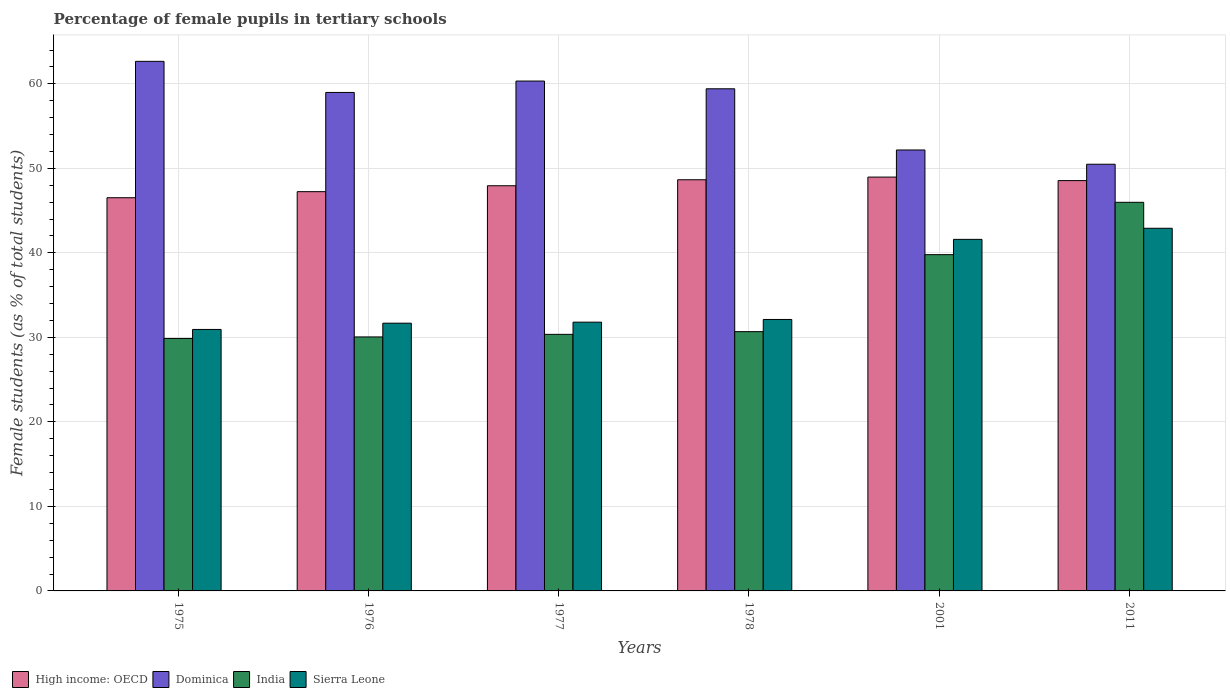How many bars are there on the 3rd tick from the right?
Your answer should be compact. 4. What is the label of the 2nd group of bars from the left?
Offer a terse response. 1976. What is the percentage of female pupils in tertiary schools in High income: OECD in 1978?
Offer a very short reply. 48.65. Across all years, what is the maximum percentage of female pupils in tertiary schools in Sierra Leone?
Your response must be concise. 42.91. Across all years, what is the minimum percentage of female pupils in tertiary schools in India?
Your response must be concise. 29.87. In which year was the percentage of female pupils in tertiary schools in High income: OECD maximum?
Offer a terse response. 2001. In which year was the percentage of female pupils in tertiary schools in India minimum?
Your answer should be very brief. 1975. What is the total percentage of female pupils in tertiary schools in Dominica in the graph?
Make the answer very short. 344.04. What is the difference between the percentage of female pupils in tertiary schools in Dominica in 1977 and that in 2011?
Your answer should be compact. 9.84. What is the difference between the percentage of female pupils in tertiary schools in Sierra Leone in 2011 and the percentage of female pupils in tertiary schools in India in 1976?
Your answer should be compact. 12.86. What is the average percentage of female pupils in tertiary schools in Sierra Leone per year?
Give a very brief answer. 35.17. In the year 2001, what is the difference between the percentage of female pupils in tertiary schools in India and percentage of female pupils in tertiary schools in Dominica?
Ensure brevity in your answer.  -12.39. What is the ratio of the percentage of female pupils in tertiary schools in India in 1977 to that in 1978?
Your answer should be compact. 0.99. What is the difference between the highest and the second highest percentage of female pupils in tertiary schools in India?
Make the answer very short. 6.19. What is the difference between the highest and the lowest percentage of female pupils in tertiary schools in Dominica?
Offer a terse response. 12.17. Is the sum of the percentage of female pupils in tertiary schools in India in 1975 and 1976 greater than the maximum percentage of female pupils in tertiary schools in Dominica across all years?
Offer a very short reply. No. Is it the case that in every year, the sum of the percentage of female pupils in tertiary schools in India and percentage of female pupils in tertiary schools in High income: OECD is greater than the percentage of female pupils in tertiary schools in Sierra Leone?
Ensure brevity in your answer.  Yes. How many bars are there?
Ensure brevity in your answer.  24. Are all the bars in the graph horizontal?
Make the answer very short. No. How many years are there in the graph?
Offer a terse response. 6. What is the difference between two consecutive major ticks on the Y-axis?
Your response must be concise. 10. Does the graph contain any zero values?
Make the answer very short. No. Does the graph contain grids?
Give a very brief answer. Yes. How are the legend labels stacked?
Your answer should be compact. Horizontal. What is the title of the graph?
Ensure brevity in your answer.  Percentage of female pupils in tertiary schools. What is the label or title of the Y-axis?
Give a very brief answer. Female students (as % of total students). What is the Female students (as % of total students) of High income: OECD in 1975?
Your response must be concise. 46.52. What is the Female students (as % of total students) in Dominica in 1975?
Your response must be concise. 62.66. What is the Female students (as % of total students) of India in 1975?
Offer a terse response. 29.87. What is the Female students (as % of total students) in Sierra Leone in 1975?
Provide a succinct answer. 30.94. What is the Female students (as % of total students) in High income: OECD in 1976?
Offer a very short reply. 47.24. What is the Female students (as % of total students) of Dominica in 1976?
Provide a succinct answer. 58.98. What is the Female students (as % of total students) of India in 1976?
Your answer should be compact. 30.05. What is the Female students (as % of total students) of Sierra Leone in 1976?
Offer a very short reply. 31.68. What is the Female students (as % of total students) in High income: OECD in 1977?
Make the answer very short. 47.94. What is the Female students (as % of total students) of Dominica in 1977?
Provide a succinct answer. 60.33. What is the Female students (as % of total students) in India in 1977?
Keep it short and to the point. 30.36. What is the Female students (as % of total students) in Sierra Leone in 1977?
Provide a short and direct response. 31.8. What is the Female students (as % of total students) in High income: OECD in 1978?
Your answer should be very brief. 48.65. What is the Female students (as % of total students) of Dominica in 1978?
Provide a succinct answer. 59.41. What is the Female students (as % of total students) in India in 1978?
Your response must be concise. 30.68. What is the Female students (as % of total students) of Sierra Leone in 1978?
Give a very brief answer. 32.12. What is the Female students (as % of total students) of High income: OECD in 2001?
Offer a terse response. 48.97. What is the Female students (as % of total students) of Dominica in 2001?
Provide a short and direct response. 52.17. What is the Female students (as % of total students) in India in 2001?
Give a very brief answer. 39.79. What is the Female students (as % of total students) in Sierra Leone in 2001?
Ensure brevity in your answer.  41.6. What is the Female students (as % of total students) of High income: OECD in 2011?
Your answer should be compact. 48.55. What is the Female students (as % of total students) of Dominica in 2011?
Your answer should be compact. 50.48. What is the Female students (as % of total students) in India in 2011?
Ensure brevity in your answer.  45.98. What is the Female students (as % of total students) of Sierra Leone in 2011?
Provide a short and direct response. 42.91. Across all years, what is the maximum Female students (as % of total students) in High income: OECD?
Give a very brief answer. 48.97. Across all years, what is the maximum Female students (as % of total students) in Dominica?
Your response must be concise. 62.66. Across all years, what is the maximum Female students (as % of total students) in India?
Keep it short and to the point. 45.98. Across all years, what is the maximum Female students (as % of total students) of Sierra Leone?
Your answer should be compact. 42.91. Across all years, what is the minimum Female students (as % of total students) of High income: OECD?
Provide a succinct answer. 46.52. Across all years, what is the minimum Female students (as % of total students) of Dominica?
Provide a succinct answer. 50.48. Across all years, what is the minimum Female students (as % of total students) in India?
Provide a short and direct response. 29.87. Across all years, what is the minimum Female students (as % of total students) of Sierra Leone?
Offer a terse response. 30.94. What is the total Female students (as % of total students) of High income: OECD in the graph?
Offer a terse response. 287.87. What is the total Female students (as % of total students) in Dominica in the graph?
Offer a very short reply. 344.04. What is the total Female students (as % of total students) of India in the graph?
Offer a very short reply. 206.73. What is the total Female students (as % of total students) of Sierra Leone in the graph?
Your answer should be very brief. 211.04. What is the difference between the Female students (as % of total students) of High income: OECD in 1975 and that in 1976?
Provide a succinct answer. -0.72. What is the difference between the Female students (as % of total students) in Dominica in 1975 and that in 1976?
Give a very brief answer. 3.68. What is the difference between the Female students (as % of total students) in India in 1975 and that in 1976?
Provide a short and direct response. -0.18. What is the difference between the Female students (as % of total students) of Sierra Leone in 1975 and that in 1976?
Offer a terse response. -0.74. What is the difference between the Female students (as % of total students) in High income: OECD in 1975 and that in 1977?
Give a very brief answer. -1.42. What is the difference between the Female students (as % of total students) of Dominica in 1975 and that in 1977?
Your answer should be compact. 2.33. What is the difference between the Female students (as % of total students) of India in 1975 and that in 1977?
Offer a terse response. -0.49. What is the difference between the Female students (as % of total students) of Sierra Leone in 1975 and that in 1977?
Your answer should be compact. -0.86. What is the difference between the Female students (as % of total students) of High income: OECD in 1975 and that in 1978?
Your answer should be compact. -2.13. What is the difference between the Female students (as % of total students) in Dominica in 1975 and that in 1978?
Provide a short and direct response. 3.25. What is the difference between the Female students (as % of total students) of India in 1975 and that in 1978?
Your answer should be compact. -0.81. What is the difference between the Female students (as % of total students) in Sierra Leone in 1975 and that in 1978?
Ensure brevity in your answer.  -1.18. What is the difference between the Female students (as % of total students) in High income: OECD in 1975 and that in 2001?
Provide a succinct answer. -2.44. What is the difference between the Female students (as % of total students) of Dominica in 1975 and that in 2001?
Offer a terse response. 10.49. What is the difference between the Female students (as % of total students) of India in 1975 and that in 2001?
Provide a succinct answer. -9.92. What is the difference between the Female students (as % of total students) in Sierra Leone in 1975 and that in 2001?
Provide a short and direct response. -10.66. What is the difference between the Female students (as % of total students) in High income: OECD in 1975 and that in 2011?
Provide a short and direct response. -2.03. What is the difference between the Female students (as % of total students) in Dominica in 1975 and that in 2011?
Your answer should be very brief. 12.17. What is the difference between the Female students (as % of total students) of India in 1975 and that in 2011?
Give a very brief answer. -16.11. What is the difference between the Female students (as % of total students) in Sierra Leone in 1975 and that in 2011?
Give a very brief answer. -11.97. What is the difference between the Female students (as % of total students) of High income: OECD in 1976 and that in 1977?
Provide a short and direct response. -0.7. What is the difference between the Female students (as % of total students) of Dominica in 1976 and that in 1977?
Your answer should be very brief. -1.35. What is the difference between the Female students (as % of total students) in India in 1976 and that in 1977?
Provide a succinct answer. -0.3. What is the difference between the Female students (as % of total students) in Sierra Leone in 1976 and that in 1977?
Ensure brevity in your answer.  -0.12. What is the difference between the Female students (as % of total students) of High income: OECD in 1976 and that in 1978?
Offer a very short reply. -1.41. What is the difference between the Female students (as % of total students) in Dominica in 1976 and that in 1978?
Your answer should be very brief. -0.43. What is the difference between the Female students (as % of total students) of India in 1976 and that in 1978?
Your answer should be compact. -0.63. What is the difference between the Female students (as % of total students) of Sierra Leone in 1976 and that in 1978?
Make the answer very short. -0.44. What is the difference between the Female students (as % of total students) in High income: OECD in 1976 and that in 2001?
Your answer should be compact. -1.72. What is the difference between the Female students (as % of total students) of Dominica in 1976 and that in 2001?
Offer a terse response. 6.81. What is the difference between the Female students (as % of total students) in India in 1976 and that in 2001?
Keep it short and to the point. -9.73. What is the difference between the Female students (as % of total students) in Sierra Leone in 1976 and that in 2001?
Provide a succinct answer. -9.92. What is the difference between the Female students (as % of total students) of High income: OECD in 1976 and that in 2011?
Your answer should be compact. -1.31. What is the difference between the Female students (as % of total students) in Dominica in 1976 and that in 2011?
Keep it short and to the point. 8.5. What is the difference between the Female students (as % of total students) of India in 1976 and that in 2011?
Ensure brevity in your answer.  -15.93. What is the difference between the Female students (as % of total students) in Sierra Leone in 1976 and that in 2011?
Keep it short and to the point. -11.23. What is the difference between the Female students (as % of total students) of High income: OECD in 1977 and that in 1978?
Your response must be concise. -0.71. What is the difference between the Female students (as % of total students) of Dominica in 1977 and that in 1978?
Offer a very short reply. 0.92. What is the difference between the Female students (as % of total students) in India in 1977 and that in 1978?
Offer a terse response. -0.32. What is the difference between the Female students (as % of total students) of Sierra Leone in 1977 and that in 1978?
Offer a terse response. -0.32. What is the difference between the Female students (as % of total students) of High income: OECD in 1977 and that in 2001?
Your response must be concise. -1.02. What is the difference between the Female students (as % of total students) of Dominica in 1977 and that in 2001?
Offer a terse response. 8.16. What is the difference between the Female students (as % of total students) of India in 1977 and that in 2001?
Give a very brief answer. -9.43. What is the difference between the Female students (as % of total students) of Sierra Leone in 1977 and that in 2001?
Ensure brevity in your answer.  -9.8. What is the difference between the Female students (as % of total students) in High income: OECD in 1977 and that in 2011?
Your answer should be compact. -0.61. What is the difference between the Female students (as % of total students) of Dominica in 1977 and that in 2011?
Your answer should be very brief. 9.84. What is the difference between the Female students (as % of total students) of India in 1977 and that in 2011?
Offer a terse response. -15.62. What is the difference between the Female students (as % of total students) in Sierra Leone in 1977 and that in 2011?
Ensure brevity in your answer.  -11.11. What is the difference between the Female students (as % of total students) of High income: OECD in 1978 and that in 2001?
Your answer should be compact. -0.32. What is the difference between the Female students (as % of total students) in Dominica in 1978 and that in 2001?
Offer a very short reply. 7.24. What is the difference between the Female students (as % of total students) in India in 1978 and that in 2001?
Your answer should be very brief. -9.11. What is the difference between the Female students (as % of total students) in Sierra Leone in 1978 and that in 2001?
Your answer should be compact. -9.48. What is the difference between the Female students (as % of total students) in High income: OECD in 1978 and that in 2011?
Make the answer very short. 0.1. What is the difference between the Female students (as % of total students) in Dominica in 1978 and that in 2011?
Ensure brevity in your answer.  8.93. What is the difference between the Female students (as % of total students) in India in 1978 and that in 2011?
Give a very brief answer. -15.3. What is the difference between the Female students (as % of total students) of Sierra Leone in 1978 and that in 2011?
Make the answer very short. -10.79. What is the difference between the Female students (as % of total students) in High income: OECD in 2001 and that in 2011?
Your answer should be compact. 0.42. What is the difference between the Female students (as % of total students) in Dominica in 2001 and that in 2011?
Offer a very short reply. 1.69. What is the difference between the Female students (as % of total students) of India in 2001 and that in 2011?
Keep it short and to the point. -6.19. What is the difference between the Female students (as % of total students) in Sierra Leone in 2001 and that in 2011?
Make the answer very short. -1.31. What is the difference between the Female students (as % of total students) of High income: OECD in 1975 and the Female students (as % of total students) of Dominica in 1976?
Your answer should be very brief. -12.46. What is the difference between the Female students (as % of total students) in High income: OECD in 1975 and the Female students (as % of total students) in India in 1976?
Offer a very short reply. 16.47. What is the difference between the Female students (as % of total students) of High income: OECD in 1975 and the Female students (as % of total students) of Sierra Leone in 1976?
Your answer should be compact. 14.84. What is the difference between the Female students (as % of total students) in Dominica in 1975 and the Female students (as % of total students) in India in 1976?
Provide a short and direct response. 32.61. What is the difference between the Female students (as % of total students) of Dominica in 1975 and the Female students (as % of total students) of Sierra Leone in 1976?
Your answer should be compact. 30.98. What is the difference between the Female students (as % of total students) of India in 1975 and the Female students (as % of total students) of Sierra Leone in 1976?
Provide a short and direct response. -1.81. What is the difference between the Female students (as % of total students) in High income: OECD in 1975 and the Female students (as % of total students) in Dominica in 1977?
Your answer should be compact. -13.81. What is the difference between the Female students (as % of total students) in High income: OECD in 1975 and the Female students (as % of total students) in India in 1977?
Your answer should be very brief. 16.17. What is the difference between the Female students (as % of total students) in High income: OECD in 1975 and the Female students (as % of total students) in Sierra Leone in 1977?
Ensure brevity in your answer.  14.72. What is the difference between the Female students (as % of total students) of Dominica in 1975 and the Female students (as % of total students) of India in 1977?
Offer a terse response. 32.3. What is the difference between the Female students (as % of total students) in Dominica in 1975 and the Female students (as % of total students) in Sierra Leone in 1977?
Offer a very short reply. 30.86. What is the difference between the Female students (as % of total students) of India in 1975 and the Female students (as % of total students) of Sierra Leone in 1977?
Provide a short and direct response. -1.93. What is the difference between the Female students (as % of total students) of High income: OECD in 1975 and the Female students (as % of total students) of Dominica in 1978?
Keep it short and to the point. -12.89. What is the difference between the Female students (as % of total students) of High income: OECD in 1975 and the Female students (as % of total students) of India in 1978?
Provide a succinct answer. 15.85. What is the difference between the Female students (as % of total students) in High income: OECD in 1975 and the Female students (as % of total students) in Sierra Leone in 1978?
Make the answer very short. 14.4. What is the difference between the Female students (as % of total students) in Dominica in 1975 and the Female students (as % of total students) in India in 1978?
Make the answer very short. 31.98. What is the difference between the Female students (as % of total students) in Dominica in 1975 and the Female students (as % of total students) in Sierra Leone in 1978?
Provide a succinct answer. 30.54. What is the difference between the Female students (as % of total students) in India in 1975 and the Female students (as % of total students) in Sierra Leone in 1978?
Offer a terse response. -2.25. What is the difference between the Female students (as % of total students) in High income: OECD in 1975 and the Female students (as % of total students) in Dominica in 2001?
Provide a succinct answer. -5.65. What is the difference between the Female students (as % of total students) in High income: OECD in 1975 and the Female students (as % of total students) in India in 2001?
Offer a terse response. 6.74. What is the difference between the Female students (as % of total students) of High income: OECD in 1975 and the Female students (as % of total students) of Sierra Leone in 2001?
Offer a terse response. 4.93. What is the difference between the Female students (as % of total students) in Dominica in 1975 and the Female students (as % of total students) in India in 2001?
Offer a very short reply. 22.87. What is the difference between the Female students (as % of total students) in Dominica in 1975 and the Female students (as % of total students) in Sierra Leone in 2001?
Make the answer very short. 21.06. What is the difference between the Female students (as % of total students) in India in 1975 and the Female students (as % of total students) in Sierra Leone in 2001?
Your response must be concise. -11.73. What is the difference between the Female students (as % of total students) of High income: OECD in 1975 and the Female students (as % of total students) of Dominica in 2011?
Provide a succinct answer. -3.96. What is the difference between the Female students (as % of total students) in High income: OECD in 1975 and the Female students (as % of total students) in India in 2011?
Ensure brevity in your answer.  0.54. What is the difference between the Female students (as % of total students) of High income: OECD in 1975 and the Female students (as % of total students) of Sierra Leone in 2011?
Ensure brevity in your answer.  3.61. What is the difference between the Female students (as % of total students) of Dominica in 1975 and the Female students (as % of total students) of India in 2011?
Ensure brevity in your answer.  16.68. What is the difference between the Female students (as % of total students) of Dominica in 1975 and the Female students (as % of total students) of Sierra Leone in 2011?
Provide a succinct answer. 19.75. What is the difference between the Female students (as % of total students) in India in 1975 and the Female students (as % of total students) in Sierra Leone in 2011?
Provide a succinct answer. -13.04. What is the difference between the Female students (as % of total students) of High income: OECD in 1976 and the Female students (as % of total students) of Dominica in 1977?
Offer a terse response. -13.09. What is the difference between the Female students (as % of total students) of High income: OECD in 1976 and the Female students (as % of total students) of India in 1977?
Ensure brevity in your answer.  16.88. What is the difference between the Female students (as % of total students) of High income: OECD in 1976 and the Female students (as % of total students) of Sierra Leone in 1977?
Keep it short and to the point. 15.44. What is the difference between the Female students (as % of total students) in Dominica in 1976 and the Female students (as % of total students) in India in 1977?
Your answer should be compact. 28.62. What is the difference between the Female students (as % of total students) of Dominica in 1976 and the Female students (as % of total students) of Sierra Leone in 1977?
Provide a succinct answer. 27.18. What is the difference between the Female students (as % of total students) in India in 1976 and the Female students (as % of total students) in Sierra Leone in 1977?
Offer a terse response. -1.75. What is the difference between the Female students (as % of total students) of High income: OECD in 1976 and the Female students (as % of total students) of Dominica in 1978?
Provide a short and direct response. -12.17. What is the difference between the Female students (as % of total students) in High income: OECD in 1976 and the Female students (as % of total students) in India in 1978?
Give a very brief answer. 16.56. What is the difference between the Female students (as % of total students) of High income: OECD in 1976 and the Female students (as % of total students) of Sierra Leone in 1978?
Your answer should be very brief. 15.12. What is the difference between the Female students (as % of total students) in Dominica in 1976 and the Female students (as % of total students) in India in 1978?
Keep it short and to the point. 28.3. What is the difference between the Female students (as % of total students) of Dominica in 1976 and the Female students (as % of total students) of Sierra Leone in 1978?
Offer a very short reply. 26.86. What is the difference between the Female students (as % of total students) of India in 1976 and the Female students (as % of total students) of Sierra Leone in 1978?
Provide a succinct answer. -2.07. What is the difference between the Female students (as % of total students) of High income: OECD in 1976 and the Female students (as % of total students) of Dominica in 2001?
Provide a short and direct response. -4.93. What is the difference between the Female students (as % of total students) of High income: OECD in 1976 and the Female students (as % of total students) of India in 2001?
Ensure brevity in your answer.  7.45. What is the difference between the Female students (as % of total students) of High income: OECD in 1976 and the Female students (as % of total students) of Sierra Leone in 2001?
Ensure brevity in your answer.  5.64. What is the difference between the Female students (as % of total students) of Dominica in 1976 and the Female students (as % of total students) of India in 2001?
Your answer should be very brief. 19.19. What is the difference between the Female students (as % of total students) in Dominica in 1976 and the Female students (as % of total students) in Sierra Leone in 2001?
Your answer should be very brief. 17.38. What is the difference between the Female students (as % of total students) in India in 1976 and the Female students (as % of total students) in Sierra Leone in 2001?
Give a very brief answer. -11.54. What is the difference between the Female students (as % of total students) of High income: OECD in 1976 and the Female students (as % of total students) of Dominica in 2011?
Your response must be concise. -3.24. What is the difference between the Female students (as % of total students) in High income: OECD in 1976 and the Female students (as % of total students) in India in 2011?
Make the answer very short. 1.26. What is the difference between the Female students (as % of total students) of High income: OECD in 1976 and the Female students (as % of total students) of Sierra Leone in 2011?
Give a very brief answer. 4.33. What is the difference between the Female students (as % of total students) of Dominica in 1976 and the Female students (as % of total students) of India in 2011?
Offer a terse response. 13. What is the difference between the Female students (as % of total students) in Dominica in 1976 and the Female students (as % of total students) in Sierra Leone in 2011?
Your answer should be very brief. 16.07. What is the difference between the Female students (as % of total students) of India in 1976 and the Female students (as % of total students) of Sierra Leone in 2011?
Provide a short and direct response. -12.86. What is the difference between the Female students (as % of total students) of High income: OECD in 1977 and the Female students (as % of total students) of Dominica in 1978?
Give a very brief answer. -11.47. What is the difference between the Female students (as % of total students) of High income: OECD in 1977 and the Female students (as % of total students) of India in 1978?
Make the answer very short. 17.26. What is the difference between the Female students (as % of total students) of High income: OECD in 1977 and the Female students (as % of total students) of Sierra Leone in 1978?
Make the answer very short. 15.82. What is the difference between the Female students (as % of total students) in Dominica in 1977 and the Female students (as % of total students) in India in 1978?
Keep it short and to the point. 29.65. What is the difference between the Female students (as % of total students) of Dominica in 1977 and the Female students (as % of total students) of Sierra Leone in 1978?
Your response must be concise. 28.21. What is the difference between the Female students (as % of total students) in India in 1977 and the Female students (as % of total students) in Sierra Leone in 1978?
Your answer should be very brief. -1.76. What is the difference between the Female students (as % of total students) in High income: OECD in 1977 and the Female students (as % of total students) in Dominica in 2001?
Your response must be concise. -4.23. What is the difference between the Female students (as % of total students) of High income: OECD in 1977 and the Female students (as % of total students) of India in 2001?
Your answer should be compact. 8.15. What is the difference between the Female students (as % of total students) in High income: OECD in 1977 and the Female students (as % of total students) in Sierra Leone in 2001?
Make the answer very short. 6.34. What is the difference between the Female students (as % of total students) of Dominica in 1977 and the Female students (as % of total students) of India in 2001?
Provide a short and direct response. 20.54. What is the difference between the Female students (as % of total students) of Dominica in 1977 and the Female students (as % of total students) of Sierra Leone in 2001?
Your answer should be very brief. 18.73. What is the difference between the Female students (as % of total students) of India in 1977 and the Female students (as % of total students) of Sierra Leone in 2001?
Your answer should be very brief. -11.24. What is the difference between the Female students (as % of total students) of High income: OECD in 1977 and the Female students (as % of total students) of Dominica in 2011?
Offer a very short reply. -2.54. What is the difference between the Female students (as % of total students) in High income: OECD in 1977 and the Female students (as % of total students) in India in 2011?
Provide a short and direct response. 1.96. What is the difference between the Female students (as % of total students) of High income: OECD in 1977 and the Female students (as % of total students) of Sierra Leone in 2011?
Provide a succinct answer. 5.03. What is the difference between the Female students (as % of total students) of Dominica in 1977 and the Female students (as % of total students) of India in 2011?
Ensure brevity in your answer.  14.35. What is the difference between the Female students (as % of total students) of Dominica in 1977 and the Female students (as % of total students) of Sierra Leone in 2011?
Offer a terse response. 17.42. What is the difference between the Female students (as % of total students) in India in 1977 and the Female students (as % of total students) in Sierra Leone in 2011?
Give a very brief answer. -12.55. What is the difference between the Female students (as % of total students) in High income: OECD in 1978 and the Female students (as % of total students) in Dominica in 2001?
Make the answer very short. -3.52. What is the difference between the Female students (as % of total students) of High income: OECD in 1978 and the Female students (as % of total students) of India in 2001?
Provide a short and direct response. 8.86. What is the difference between the Female students (as % of total students) in High income: OECD in 1978 and the Female students (as % of total students) in Sierra Leone in 2001?
Offer a terse response. 7.05. What is the difference between the Female students (as % of total students) in Dominica in 1978 and the Female students (as % of total students) in India in 2001?
Provide a succinct answer. 19.63. What is the difference between the Female students (as % of total students) of Dominica in 1978 and the Female students (as % of total students) of Sierra Leone in 2001?
Keep it short and to the point. 17.82. What is the difference between the Female students (as % of total students) of India in 1978 and the Female students (as % of total students) of Sierra Leone in 2001?
Offer a very short reply. -10.92. What is the difference between the Female students (as % of total students) in High income: OECD in 1978 and the Female students (as % of total students) in Dominica in 2011?
Your response must be concise. -1.83. What is the difference between the Female students (as % of total students) of High income: OECD in 1978 and the Female students (as % of total students) of India in 2011?
Give a very brief answer. 2.67. What is the difference between the Female students (as % of total students) in High income: OECD in 1978 and the Female students (as % of total students) in Sierra Leone in 2011?
Provide a short and direct response. 5.74. What is the difference between the Female students (as % of total students) of Dominica in 1978 and the Female students (as % of total students) of India in 2011?
Your answer should be very brief. 13.43. What is the difference between the Female students (as % of total students) in Dominica in 1978 and the Female students (as % of total students) in Sierra Leone in 2011?
Give a very brief answer. 16.5. What is the difference between the Female students (as % of total students) in India in 1978 and the Female students (as % of total students) in Sierra Leone in 2011?
Give a very brief answer. -12.23. What is the difference between the Female students (as % of total students) in High income: OECD in 2001 and the Female students (as % of total students) in Dominica in 2011?
Offer a terse response. -1.52. What is the difference between the Female students (as % of total students) of High income: OECD in 2001 and the Female students (as % of total students) of India in 2011?
Your response must be concise. 2.98. What is the difference between the Female students (as % of total students) of High income: OECD in 2001 and the Female students (as % of total students) of Sierra Leone in 2011?
Ensure brevity in your answer.  6.06. What is the difference between the Female students (as % of total students) of Dominica in 2001 and the Female students (as % of total students) of India in 2011?
Ensure brevity in your answer.  6.19. What is the difference between the Female students (as % of total students) of Dominica in 2001 and the Female students (as % of total students) of Sierra Leone in 2011?
Offer a very short reply. 9.26. What is the difference between the Female students (as % of total students) of India in 2001 and the Female students (as % of total students) of Sierra Leone in 2011?
Keep it short and to the point. -3.12. What is the average Female students (as % of total students) in High income: OECD per year?
Your answer should be very brief. 47.98. What is the average Female students (as % of total students) in Dominica per year?
Make the answer very short. 57.34. What is the average Female students (as % of total students) in India per year?
Provide a short and direct response. 34.45. What is the average Female students (as % of total students) of Sierra Leone per year?
Your answer should be very brief. 35.17. In the year 1975, what is the difference between the Female students (as % of total students) in High income: OECD and Female students (as % of total students) in Dominica?
Your answer should be compact. -16.14. In the year 1975, what is the difference between the Female students (as % of total students) of High income: OECD and Female students (as % of total students) of India?
Offer a very short reply. 16.65. In the year 1975, what is the difference between the Female students (as % of total students) of High income: OECD and Female students (as % of total students) of Sierra Leone?
Ensure brevity in your answer.  15.59. In the year 1975, what is the difference between the Female students (as % of total students) in Dominica and Female students (as % of total students) in India?
Provide a short and direct response. 32.79. In the year 1975, what is the difference between the Female students (as % of total students) of Dominica and Female students (as % of total students) of Sierra Leone?
Your answer should be compact. 31.72. In the year 1975, what is the difference between the Female students (as % of total students) of India and Female students (as % of total students) of Sierra Leone?
Provide a succinct answer. -1.07. In the year 1976, what is the difference between the Female students (as % of total students) of High income: OECD and Female students (as % of total students) of Dominica?
Offer a very short reply. -11.74. In the year 1976, what is the difference between the Female students (as % of total students) of High income: OECD and Female students (as % of total students) of India?
Your response must be concise. 17.19. In the year 1976, what is the difference between the Female students (as % of total students) in High income: OECD and Female students (as % of total students) in Sierra Leone?
Provide a succinct answer. 15.56. In the year 1976, what is the difference between the Female students (as % of total students) in Dominica and Female students (as % of total students) in India?
Your answer should be very brief. 28.93. In the year 1976, what is the difference between the Female students (as % of total students) of Dominica and Female students (as % of total students) of Sierra Leone?
Offer a terse response. 27.3. In the year 1976, what is the difference between the Female students (as % of total students) of India and Female students (as % of total students) of Sierra Leone?
Offer a very short reply. -1.63. In the year 1977, what is the difference between the Female students (as % of total students) in High income: OECD and Female students (as % of total students) in Dominica?
Offer a very short reply. -12.39. In the year 1977, what is the difference between the Female students (as % of total students) of High income: OECD and Female students (as % of total students) of India?
Make the answer very short. 17.58. In the year 1977, what is the difference between the Female students (as % of total students) of High income: OECD and Female students (as % of total students) of Sierra Leone?
Ensure brevity in your answer.  16.14. In the year 1977, what is the difference between the Female students (as % of total students) of Dominica and Female students (as % of total students) of India?
Your response must be concise. 29.97. In the year 1977, what is the difference between the Female students (as % of total students) of Dominica and Female students (as % of total students) of Sierra Leone?
Your response must be concise. 28.53. In the year 1977, what is the difference between the Female students (as % of total students) in India and Female students (as % of total students) in Sierra Leone?
Your response must be concise. -1.44. In the year 1978, what is the difference between the Female students (as % of total students) in High income: OECD and Female students (as % of total students) in Dominica?
Provide a succinct answer. -10.76. In the year 1978, what is the difference between the Female students (as % of total students) in High income: OECD and Female students (as % of total students) in India?
Offer a very short reply. 17.97. In the year 1978, what is the difference between the Female students (as % of total students) in High income: OECD and Female students (as % of total students) in Sierra Leone?
Provide a short and direct response. 16.53. In the year 1978, what is the difference between the Female students (as % of total students) of Dominica and Female students (as % of total students) of India?
Give a very brief answer. 28.74. In the year 1978, what is the difference between the Female students (as % of total students) of Dominica and Female students (as % of total students) of Sierra Leone?
Make the answer very short. 27.29. In the year 1978, what is the difference between the Female students (as % of total students) in India and Female students (as % of total students) in Sierra Leone?
Your answer should be very brief. -1.44. In the year 2001, what is the difference between the Female students (as % of total students) of High income: OECD and Female students (as % of total students) of Dominica?
Ensure brevity in your answer.  -3.21. In the year 2001, what is the difference between the Female students (as % of total students) of High income: OECD and Female students (as % of total students) of India?
Your response must be concise. 9.18. In the year 2001, what is the difference between the Female students (as % of total students) in High income: OECD and Female students (as % of total students) in Sierra Leone?
Keep it short and to the point. 7.37. In the year 2001, what is the difference between the Female students (as % of total students) in Dominica and Female students (as % of total students) in India?
Your response must be concise. 12.39. In the year 2001, what is the difference between the Female students (as % of total students) in Dominica and Female students (as % of total students) in Sierra Leone?
Offer a terse response. 10.58. In the year 2001, what is the difference between the Female students (as % of total students) of India and Female students (as % of total students) of Sierra Leone?
Offer a terse response. -1.81. In the year 2011, what is the difference between the Female students (as % of total students) in High income: OECD and Female students (as % of total students) in Dominica?
Your answer should be very brief. -1.94. In the year 2011, what is the difference between the Female students (as % of total students) in High income: OECD and Female students (as % of total students) in India?
Keep it short and to the point. 2.57. In the year 2011, what is the difference between the Female students (as % of total students) of High income: OECD and Female students (as % of total students) of Sierra Leone?
Offer a very short reply. 5.64. In the year 2011, what is the difference between the Female students (as % of total students) of Dominica and Female students (as % of total students) of India?
Keep it short and to the point. 4.5. In the year 2011, what is the difference between the Female students (as % of total students) in Dominica and Female students (as % of total students) in Sierra Leone?
Your response must be concise. 7.58. In the year 2011, what is the difference between the Female students (as % of total students) of India and Female students (as % of total students) of Sierra Leone?
Your answer should be very brief. 3.07. What is the ratio of the Female students (as % of total students) in Dominica in 1975 to that in 1976?
Your answer should be very brief. 1.06. What is the ratio of the Female students (as % of total students) of India in 1975 to that in 1976?
Your answer should be very brief. 0.99. What is the ratio of the Female students (as % of total students) of Sierra Leone in 1975 to that in 1976?
Your answer should be very brief. 0.98. What is the ratio of the Female students (as % of total students) in High income: OECD in 1975 to that in 1977?
Provide a short and direct response. 0.97. What is the ratio of the Female students (as % of total students) of Dominica in 1975 to that in 1977?
Keep it short and to the point. 1.04. What is the ratio of the Female students (as % of total students) in India in 1975 to that in 1977?
Ensure brevity in your answer.  0.98. What is the ratio of the Female students (as % of total students) in Sierra Leone in 1975 to that in 1977?
Offer a very short reply. 0.97. What is the ratio of the Female students (as % of total students) in High income: OECD in 1975 to that in 1978?
Offer a very short reply. 0.96. What is the ratio of the Female students (as % of total students) in Dominica in 1975 to that in 1978?
Give a very brief answer. 1.05. What is the ratio of the Female students (as % of total students) in India in 1975 to that in 1978?
Give a very brief answer. 0.97. What is the ratio of the Female students (as % of total students) of Sierra Leone in 1975 to that in 1978?
Offer a terse response. 0.96. What is the ratio of the Female students (as % of total students) in High income: OECD in 1975 to that in 2001?
Your answer should be very brief. 0.95. What is the ratio of the Female students (as % of total students) in Dominica in 1975 to that in 2001?
Make the answer very short. 1.2. What is the ratio of the Female students (as % of total students) of India in 1975 to that in 2001?
Your response must be concise. 0.75. What is the ratio of the Female students (as % of total students) of Sierra Leone in 1975 to that in 2001?
Offer a terse response. 0.74. What is the ratio of the Female students (as % of total students) in Dominica in 1975 to that in 2011?
Your answer should be compact. 1.24. What is the ratio of the Female students (as % of total students) of India in 1975 to that in 2011?
Provide a succinct answer. 0.65. What is the ratio of the Female students (as % of total students) of Sierra Leone in 1975 to that in 2011?
Offer a terse response. 0.72. What is the ratio of the Female students (as % of total students) in High income: OECD in 1976 to that in 1977?
Provide a succinct answer. 0.99. What is the ratio of the Female students (as % of total students) in Dominica in 1976 to that in 1977?
Give a very brief answer. 0.98. What is the ratio of the Female students (as % of total students) of High income: OECD in 1976 to that in 1978?
Offer a very short reply. 0.97. What is the ratio of the Female students (as % of total students) of India in 1976 to that in 1978?
Give a very brief answer. 0.98. What is the ratio of the Female students (as % of total students) in Sierra Leone in 1976 to that in 1978?
Your response must be concise. 0.99. What is the ratio of the Female students (as % of total students) of High income: OECD in 1976 to that in 2001?
Keep it short and to the point. 0.96. What is the ratio of the Female students (as % of total students) of Dominica in 1976 to that in 2001?
Keep it short and to the point. 1.13. What is the ratio of the Female students (as % of total students) in India in 1976 to that in 2001?
Provide a succinct answer. 0.76. What is the ratio of the Female students (as % of total students) of Sierra Leone in 1976 to that in 2001?
Give a very brief answer. 0.76. What is the ratio of the Female students (as % of total students) in High income: OECD in 1976 to that in 2011?
Offer a terse response. 0.97. What is the ratio of the Female students (as % of total students) in Dominica in 1976 to that in 2011?
Offer a terse response. 1.17. What is the ratio of the Female students (as % of total students) in India in 1976 to that in 2011?
Keep it short and to the point. 0.65. What is the ratio of the Female students (as % of total students) in Sierra Leone in 1976 to that in 2011?
Keep it short and to the point. 0.74. What is the ratio of the Female students (as % of total students) in High income: OECD in 1977 to that in 1978?
Give a very brief answer. 0.99. What is the ratio of the Female students (as % of total students) of Dominica in 1977 to that in 1978?
Offer a terse response. 1.02. What is the ratio of the Female students (as % of total students) of India in 1977 to that in 1978?
Provide a succinct answer. 0.99. What is the ratio of the Female students (as % of total students) in Sierra Leone in 1977 to that in 1978?
Your response must be concise. 0.99. What is the ratio of the Female students (as % of total students) in High income: OECD in 1977 to that in 2001?
Give a very brief answer. 0.98. What is the ratio of the Female students (as % of total students) in Dominica in 1977 to that in 2001?
Make the answer very short. 1.16. What is the ratio of the Female students (as % of total students) of India in 1977 to that in 2001?
Provide a succinct answer. 0.76. What is the ratio of the Female students (as % of total students) in Sierra Leone in 1977 to that in 2001?
Give a very brief answer. 0.76. What is the ratio of the Female students (as % of total students) in High income: OECD in 1977 to that in 2011?
Keep it short and to the point. 0.99. What is the ratio of the Female students (as % of total students) in Dominica in 1977 to that in 2011?
Offer a very short reply. 1.2. What is the ratio of the Female students (as % of total students) in India in 1977 to that in 2011?
Provide a succinct answer. 0.66. What is the ratio of the Female students (as % of total students) of Sierra Leone in 1977 to that in 2011?
Ensure brevity in your answer.  0.74. What is the ratio of the Female students (as % of total students) in Dominica in 1978 to that in 2001?
Provide a short and direct response. 1.14. What is the ratio of the Female students (as % of total students) of India in 1978 to that in 2001?
Offer a terse response. 0.77. What is the ratio of the Female students (as % of total students) of Sierra Leone in 1978 to that in 2001?
Your response must be concise. 0.77. What is the ratio of the Female students (as % of total students) of Dominica in 1978 to that in 2011?
Ensure brevity in your answer.  1.18. What is the ratio of the Female students (as % of total students) in India in 1978 to that in 2011?
Ensure brevity in your answer.  0.67. What is the ratio of the Female students (as % of total students) of Sierra Leone in 1978 to that in 2011?
Provide a short and direct response. 0.75. What is the ratio of the Female students (as % of total students) of High income: OECD in 2001 to that in 2011?
Ensure brevity in your answer.  1.01. What is the ratio of the Female students (as % of total students) of Dominica in 2001 to that in 2011?
Make the answer very short. 1.03. What is the ratio of the Female students (as % of total students) of India in 2001 to that in 2011?
Make the answer very short. 0.87. What is the ratio of the Female students (as % of total students) of Sierra Leone in 2001 to that in 2011?
Provide a short and direct response. 0.97. What is the difference between the highest and the second highest Female students (as % of total students) of High income: OECD?
Ensure brevity in your answer.  0.32. What is the difference between the highest and the second highest Female students (as % of total students) in Dominica?
Your answer should be very brief. 2.33. What is the difference between the highest and the second highest Female students (as % of total students) of India?
Provide a succinct answer. 6.19. What is the difference between the highest and the second highest Female students (as % of total students) of Sierra Leone?
Give a very brief answer. 1.31. What is the difference between the highest and the lowest Female students (as % of total students) of High income: OECD?
Provide a short and direct response. 2.44. What is the difference between the highest and the lowest Female students (as % of total students) of Dominica?
Your answer should be compact. 12.17. What is the difference between the highest and the lowest Female students (as % of total students) in India?
Your answer should be compact. 16.11. What is the difference between the highest and the lowest Female students (as % of total students) of Sierra Leone?
Keep it short and to the point. 11.97. 